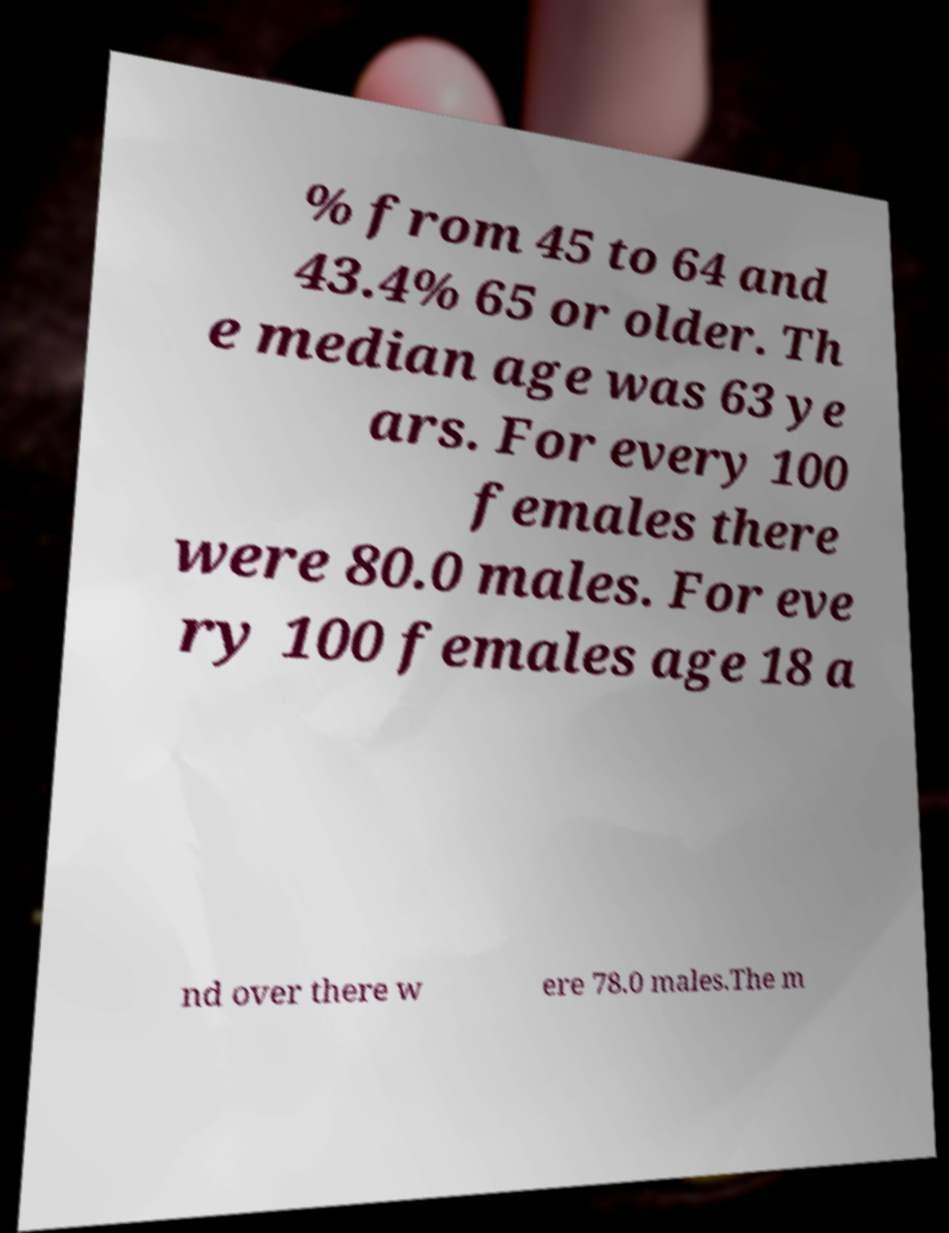Could you extract and type out the text from this image? % from 45 to 64 and 43.4% 65 or older. Th e median age was 63 ye ars. For every 100 females there were 80.0 males. For eve ry 100 females age 18 a nd over there w ere 78.0 males.The m 